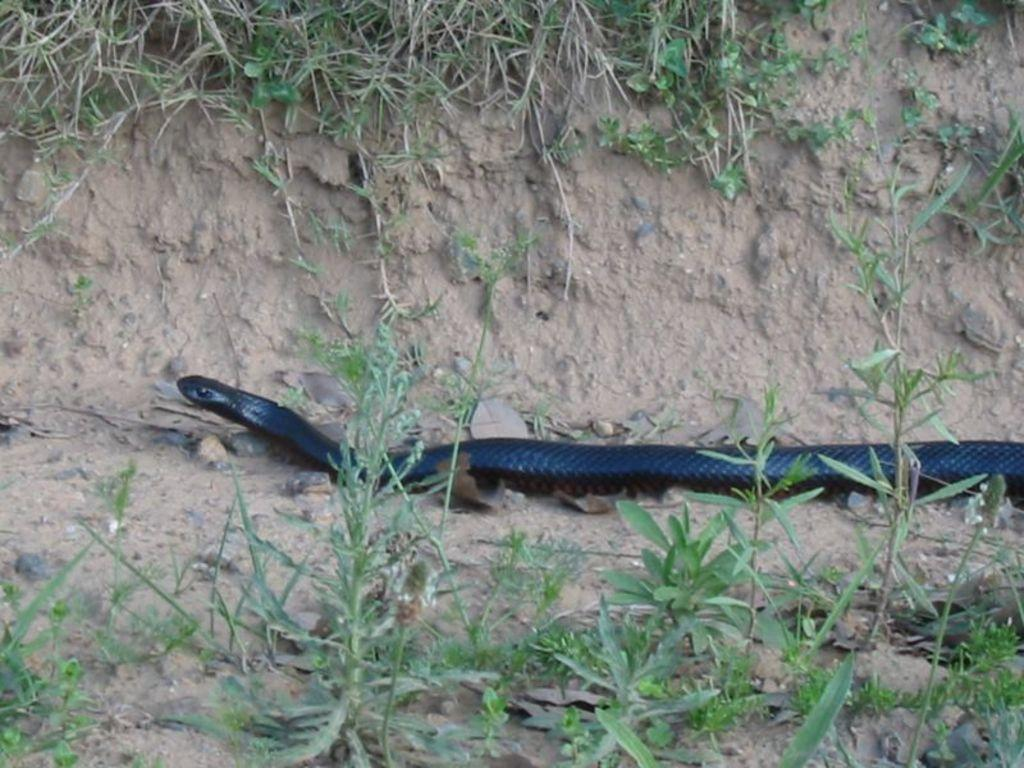What type of animal is in the image? There is a snake in the image. What else can be seen in the image besides the snake? There are plants and leaves on the ground visible in the image. What type of vegetation is present in the image? There is grass visible in the image. Where is the scarecrow located in the image? There is no scarecrow present in the image. What type of material is the snake rubbing against in the image? The snake is not shown rubbing against any material in the image. 